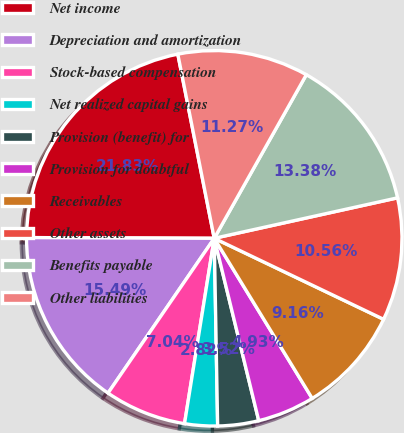Convert chart to OTSL. <chart><loc_0><loc_0><loc_500><loc_500><pie_chart><fcel>Net income<fcel>Depreciation and amortization<fcel>Stock-based compensation<fcel>Net realized capital gains<fcel>Provision (benefit) for<fcel>Provision for doubtful<fcel>Receivables<fcel>Other assets<fcel>Benefits payable<fcel>Other liabilities<nl><fcel>21.83%<fcel>15.49%<fcel>7.04%<fcel>2.82%<fcel>3.52%<fcel>4.93%<fcel>9.16%<fcel>10.56%<fcel>13.38%<fcel>11.27%<nl></chart> 